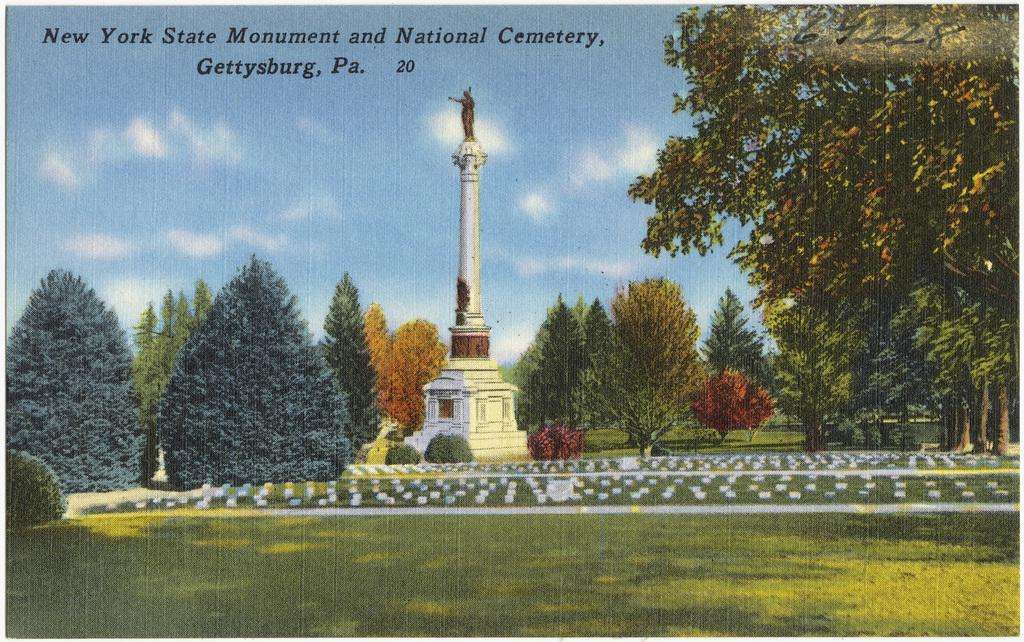What type of vegetation can be seen in the image? There are trees and plants in the image. What structure is present in the image? There is a tower in the image. What is on the ground in the image? There is grass on the ground in the image. What is the condition of the sky in the image? The sky is blue and cloudy in the image. What can be found at the top of the picture? There is text at the top of the picture. What is the chance of winning the lottery in the image? There is no mention of a lottery or any chance of winning in the image. What is the afterthought of the destruction in the image? There is no destruction or afterthought present in the image. 